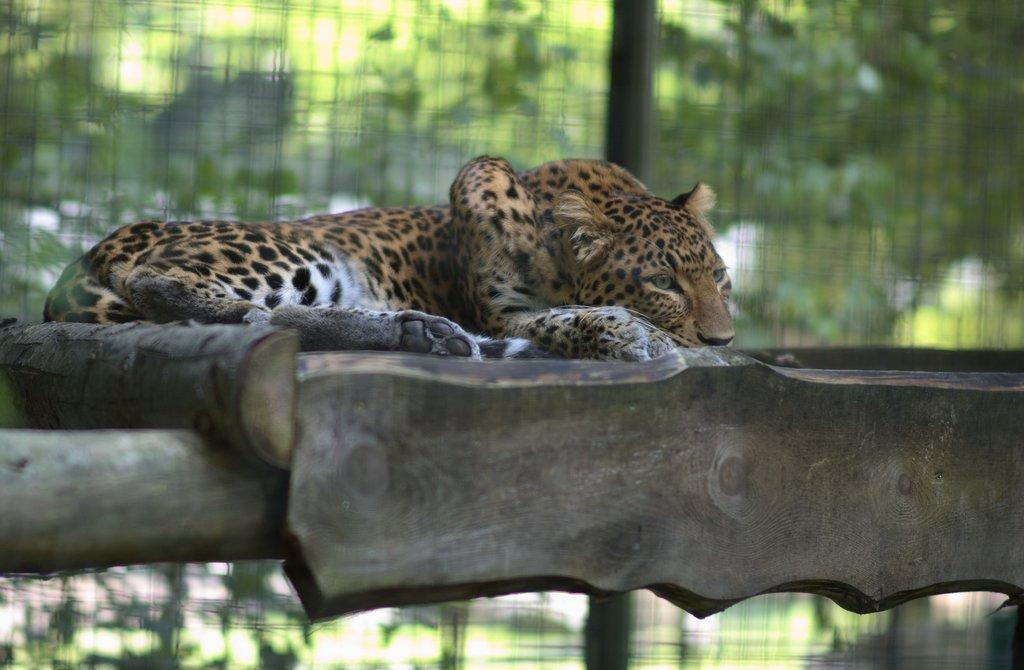What animal is the main subject of the image? There is a leopard in the image. What is the leopard resting on? The leopard is lying on a wooden object. Can you describe the background of the image? The background of the image is blurred. How much money is floating in the lake in the image? There is no lake or money present in the image; it features a leopard lying on a wooden object with a blurred background. 